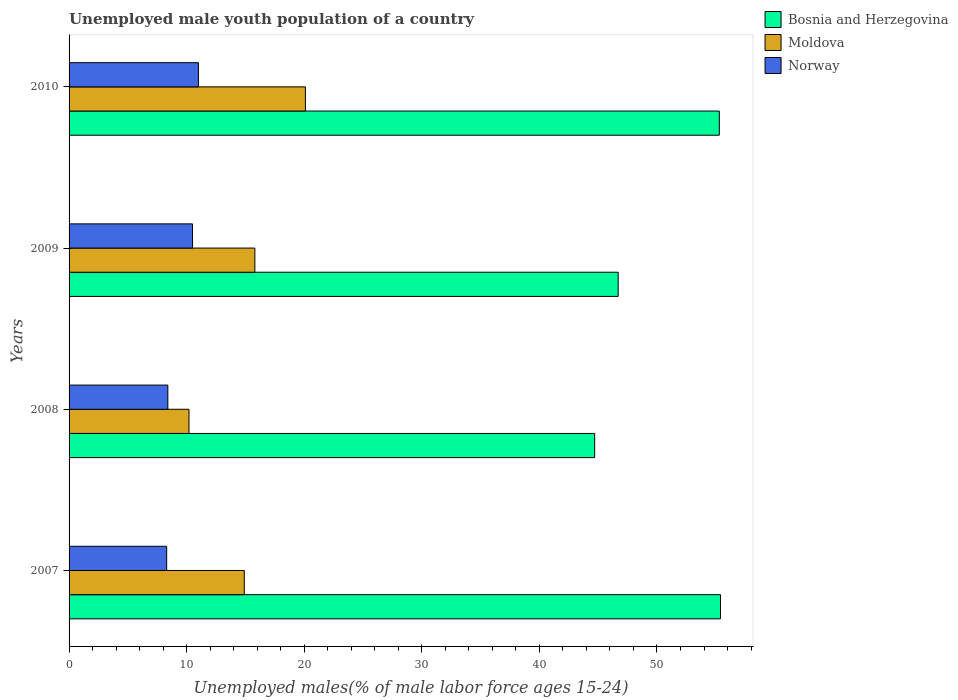How many different coloured bars are there?
Give a very brief answer. 3. How many groups of bars are there?
Give a very brief answer. 4. Are the number of bars per tick equal to the number of legend labels?
Make the answer very short. Yes. How many bars are there on the 2nd tick from the bottom?
Provide a succinct answer. 3. What is the label of the 1st group of bars from the top?
Give a very brief answer. 2010. What is the percentage of unemployed male youth population in Moldova in 2010?
Make the answer very short. 20.1. Across all years, what is the maximum percentage of unemployed male youth population in Bosnia and Herzegovina?
Provide a succinct answer. 55.4. Across all years, what is the minimum percentage of unemployed male youth population in Moldova?
Offer a terse response. 10.2. In which year was the percentage of unemployed male youth population in Norway minimum?
Your answer should be compact. 2007. What is the total percentage of unemployed male youth population in Norway in the graph?
Offer a very short reply. 38.2. What is the difference between the percentage of unemployed male youth population in Norway in 2007 and that in 2010?
Your response must be concise. -2.7. What is the difference between the percentage of unemployed male youth population in Norway in 2010 and the percentage of unemployed male youth population in Bosnia and Herzegovina in 2008?
Your response must be concise. -33.7. What is the average percentage of unemployed male youth population in Bosnia and Herzegovina per year?
Keep it short and to the point. 50.53. In the year 2010, what is the difference between the percentage of unemployed male youth population in Bosnia and Herzegovina and percentage of unemployed male youth population in Norway?
Provide a succinct answer. 44.3. What is the ratio of the percentage of unemployed male youth population in Norway in 2008 to that in 2010?
Your response must be concise. 0.76. What is the difference between the highest and the second highest percentage of unemployed male youth population in Moldova?
Your answer should be compact. 4.3. What is the difference between the highest and the lowest percentage of unemployed male youth population in Moldova?
Make the answer very short. 9.9. In how many years, is the percentage of unemployed male youth population in Moldova greater than the average percentage of unemployed male youth population in Moldova taken over all years?
Provide a short and direct response. 2. What does the 2nd bar from the top in 2007 represents?
Your answer should be compact. Moldova. Are all the bars in the graph horizontal?
Your answer should be compact. Yes. What is the difference between two consecutive major ticks on the X-axis?
Your answer should be compact. 10. Are the values on the major ticks of X-axis written in scientific E-notation?
Provide a short and direct response. No. Does the graph contain any zero values?
Offer a terse response. No. Does the graph contain grids?
Your answer should be compact. No. How many legend labels are there?
Keep it short and to the point. 3. What is the title of the graph?
Ensure brevity in your answer.  Unemployed male youth population of a country. What is the label or title of the X-axis?
Keep it short and to the point. Unemployed males(% of male labor force ages 15-24). What is the Unemployed males(% of male labor force ages 15-24) of Bosnia and Herzegovina in 2007?
Provide a short and direct response. 55.4. What is the Unemployed males(% of male labor force ages 15-24) in Moldova in 2007?
Keep it short and to the point. 14.9. What is the Unemployed males(% of male labor force ages 15-24) of Norway in 2007?
Give a very brief answer. 8.3. What is the Unemployed males(% of male labor force ages 15-24) of Bosnia and Herzegovina in 2008?
Your response must be concise. 44.7. What is the Unemployed males(% of male labor force ages 15-24) in Moldova in 2008?
Your answer should be compact. 10.2. What is the Unemployed males(% of male labor force ages 15-24) of Norway in 2008?
Your response must be concise. 8.4. What is the Unemployed males(% of male labor force ages 15-24) in Bosnia and Herzegovina in 2009?
Offer a very short reply. 46.7. What is the Unemployed males(% of male labor force ages 15-24) in Moldova in 2009?
Your response must be concise. 15.8. What is the Unemployed males(% of male labor force ages 15-24) of Norway in 2009?
Offer a terse response. 10.5. What is the Unemployed males(% of male labor force ages 15-24) in Bosnia and Herzegovina in 2010?
Your answer should be very brief. 55.3. What is the Unemployed males(% of male labor force ages 15-24) of Moldova in 2010?
Your answer should be compact. 20.1. What is the Unemployed males(% of male labor force ages 15-24) of Norway in 2010?
Ensure brevity in your answer.  11. Across all years, what is the maximum Unemployed males(% of male labor force ages 15-24) of Bosnia and Herzegovina?
Give a very brief answer. 55.4. Across all years, what is the maximum Unemployed males(% of male labor force ages 15-24) in Moldova?
Your answer should be very brief. 20.1. Across all years, what is the minimum Unemployed males(% of male labor force ages 15-24) in Bosnia and Herzegovina?
Ensure brevity in your answer.  44.7. Across all years, what is the minimum Unemployed males(% of male labor force ages 15-24) in Moldova?
Ensure brevity in your answer.  10.2. Across all years, what is the minimum Unemployed males(% of male labor force ages 15-24) of Norway?
Provide a short and direct response. 8.3. What is the total Unemployed males(% of male labor force ages 15-24) of Bosnia and Herzegovina in the graph?
Provide a short and direct response. 202.1. What is the total Unemployed males(% of male labor force ages 15-24) of Norway in the graph?
Ensure brevity in your answer.  38.2. What is the difference between the Unemployed males(% of male labor force ages 15-24) of Bosnia and Herzegovina in 2007 and that in 2010?
Your answer should be compact. 0.1. What is the difference between the Unemployed males(% of male labor force ages 15-24) in Moldova in 2007 and that in 2010?
Offer a terse response. -5.2. What is the difference between the Unemployed males(% of male labor force ages 15-24) of Norway in 2007 and that in 2010?
Your response must be concise. -2.7. What is the difference between the Unemployed males(% of male labor force ages 15-24) in Bosnia and Herzegovina in 2008 and that in 2009?
Your answer should be compact. -2. What is the difference between the Unemployed males(% of male labor force ages 15-24) of Moldova in 2008 and that in 2009?
Your answer should be compact. -5.6. What is the difference between the Unemployed males(% of male labor force ages 15-24) in Norway in 2008 and that in 2009?
Your answer should be compact. -2.1. What is the difference between the Unemployed males(% of male labor force ages 15-24) of Bosnia and Herzegovina in 2008 and that in 2010?
Make the answer very short. -10.6. What is the difference between the Unemployed males(% of male labor force ages 15-24) of Norway in 2009 and that in 2010?
Your answer should be compact. -0.5. What is the difference between the Unemployed males(% of male labor force ages 15-24) in Bosnia and Herzegovina in 2007 and the Unemployed males(% of male labor force ages 15-24) in Moldova in 2008?
Your answer should be very brief. 45.2. What is the difference between the Unemployed males(% of male labor force ages 15-24) of Bosnia and Herzegovina in 2007 and the Unemployed males(% of male labor force ages 15-24) of Norway in 2008?
Your answer should be compact. 47. What is the difference between the Unemployed males(% of male labor force ages 15-24) in Moldova in 2007 and the Unemployed males(% of male labor force ages 15-24) in Norway in 2008?
Provide a short and direct response. 6.5. What is the difference between the Unemployed males(% of male labor force ages 15-24) in Bosnia and Herzegovina in 2007 and the Unemployed males(% of male labor force ages 15-24) in Moldova in 2009?
Provide a short and direct response. 39.6. What is the difference between the Unemployed males(% of male labor force ages 15-24) in Bosnia and Herzegovina in 2007 and the Unemployed males(% of male labor force ages 15-24) in Norway in 2009?
Keep it short and to the point. 44.9. What is the difference between the Unemployed males(% of male labor force ages 15-24) of Moldova in 2007 and the Unemployed males(% of male labor force ages 15-24) of Norway in 2009?
Provide a short and direct response. 4.4. What is the difference between the Unemployed males(% of male labor force ages 15-24) in Bosnia and Herzegovina in 2007 and the Unemployed males(% of male labor force ages 15-24) in Moldova in 2010?
Keep it short and to the point. 35.3. What is the difference between the Unemployed males(% of male labor force ages 15-24) in Bosnia and Herzegovina in 2007 and the Unemployed males(% of male labor force ages 15-24) in Norway in 2010?
Provide a succinct answer. 44.4. What is the difference between the Unemployed males(% of male labor force ages 15-24) in Moldova in 2007 and the Unemployed males(% of male labor force ages 15-24) in Norway in 2010?
Your answer should be compact. 3.9. What is the difference between the Unemployed males(% of male labor force ages 15-24) of Bosnia and Herzegovina in 2008 and the Unemployed males(% of male labor force ages 15-24) of Moldova in 2009?
Ensure brevity in your answer.  28.9. What is the difference between the Unemployed males(% of male labor force ages 15-24) of Bosnia and Herzegovina in 2008 and the Unemployed males(% of male labor force ages 15-24) of Norway in 2009?
Ensure brevity in your answer.  34.2. What is the difference between the Unemployed males(% of male labor force ages 15-24) in Bosnia and Herzegovina in 2008 and the Unemployed males(% of male labor force ages 15-24) in Moldova in 2010?
Your answer should be very brief. 24.6. What is the difference between the Unemployed males(% of male labor force ages 15-24) of Bosnia and Herzegovina in 2008 and the Unemployed males(% of male labor force ages 15-24) of Norway in 2010?
Keep it short and to the point. 33.7. What is the difference between the Unemployed males(% of male labor force ages 15-24) in Moldova in 2008 and the Unemployed males(% of male labor force ages 15-24) in Norway in 2010?
Make the answer very short. -0.8. What is the difference between the Unemployed males(% of male labor force ages 15-24) in Bosnia and Herzegovina in 2009 and the Unemployed males(% of male labor force ages 15-24) in Moldova in 2010?
Provide a succinct answer. 26.6. What is the difference between the Unemployed males(% of male labor force ages 15-24) in Bosnia and Herzegovina in 2009 and the Unemployed males(% of male labor force ages 15-24) in Norway in 2010?
Offer a terse response. 35.7. What is the average Unemployed males(% of male labor force ages 15-24) of Bosnia and Herzegovina per year?
Give a very brief answer. 50.52. What is the average Unemployed males(% of male labor force ages 15-24) in Moldova per year?
Your answer should be compact. 15.25. What is the average Unemployed males(% of male labor force ages 15-24) of Norway per year?
Give a very brief answer. 9.55. In the year 2007, what is the difference between the Unemployed males(% of male labor force ages 15-24) in Bosnia and Herzegovina and Unemployed males(% of male labor force ages 15-24) in Moldova?
Provide a succinct answer. 40.5. In the year 2007, what is the difference between the Unemployed males(% of male labor force ages 15-24) in Bosnia and Herzegovina and Unemployed males(% of male labor force ages 15-24) in Norway?
Ensure brevity in your answer.  47.1. In the year 2008, what is the difference between the Unemployed males(% of male labor force ages 15-24) in Bosnia and Herzegovina and Unemployed males(% of male labor force ages 15-24) in Moldova?
Make the answer very short. 34.5. In the year 2008, what is the difference between the Unemployed males(% of male labor force ages 15-24) of Bosnia and Herzegovina and Unemployed males(% of male labor force ages 15-24) of Norway?
Give a very brief answer. 36.3. In the year 2009, what is the difference between the Unemployed males(% of male labor force ages 15-24) in Bosnia and Herzegovina and Unemployed males(% of male labor force ages 15-24) in Moldova?
Your answer should be very brief. 30.9. In the year 2009, what is the difference between the Unemployed males(% of male labor force ages 15-24) in Bosnia and Herzegovina and Unemployed males(% of male labor force ages 15-24) in Norway?
Your answer should be very brief. 36.2. In the year 2009, what is the difference between the Unemployed males(% of male labor force ages 15-24) in Moldova and Unemployed males(% of male labor force ages 15-24) in Norway?
Your answer should be very brief. 5.3. In the year 2010, what is the difference between the Unemployed males(% of male labor force ages 15-24) in Bosnia and Herzegovina and Unemployed males(% of male labor force ages 15-24) in Moldova?
Keep it short and to the point. 35.2. In the year 2010, what is the difference between the Unemployed males(% of male labor force ages 15-24) of Bosnia and Herzegovina and Unemployed males(% of male labor force ages 15-24) of Norway?
Your answer should be compact. 44.3. What is the ratio of the Unemployed males(% of male labor force ages 15-24) of Bosnia and Herzegovina in 2007 to that in 2008?
Offer a very short reply. 1.24. What is the ratio of the Unemployed males(% of male labor force ages 15-24) of Moldova in 2007 to that in 2008?
Make the answer very short. 1.46. What is the ratio of the Unemployed males(% of male labor force ages 15-24) in Norway in 2007 to that in 2008?
Your answer should be very brief. 0.99. What is the ratio of the Unemployed males(% of male labor force ages 15-24) of Bosnia and Herzegovina in 2007 to that in 2009?
Your answer should be compact. 1.19. What is the ratio of the Unemployed males(% of male labor force ages 15-24) of Moldova in 2007 to that in 2009?
Make the answer very short. 0.94. What is the ratio of the Unemployed males(% of male labor force ages 15-24) in Norway in 2007 to that in 2009?
Offer a terse response. 0.79. What is the ratio of the Unemployed males(% of male labor force ages 15-24) of Bosnia and Herzegovina in 2007 to that in 2010?
Offer a very short reply. 1. What is the ratio of the Unemployed males(% of male labor force ages 15-24) of Moldova in 2007 to that in 2010?
Make the answer very short. 0.74. What is the ratio of the Unemployed males(% of male labor force ages 15-24) of Norway in 2007 to that in 2010?
Make the answer very short. 0.75. What is the ratio of the Unemployed males(% of male labor force ages 15-24) in Bosnia and Herzegovina in 2008 to that in 2009?
Your response must be concise. 0.96. What is the ratio of the Unemployed males(% of male labor force ages 15-24) in Moldova in 2008 to that in 2009?
Provide a short and direct response. 0.65. What is the ratio of the Unemployed males(% of male labor force ages 15-24) of Bosnia and Herzegovina in 2008 to that in 2010?
Offer a very short reply. 0.81. What is the ratio of the Unemployed males(% of male labor force ages 15-24) of Moldova in 2008 to that in 2010?
Your response must be concise. 0.51. What is the ratio of the Unemployed males(% of male labor force ages 15-24) in Norway in 2008 to that in 2010?
Offer a very short reply. 0.76. What is the ratio of the Unemployed males(% of male labor force ages 15-24) of Bosnia and Herzegovina in 2009 to that in 2010?
Provide a short and direct response. 0.84. What is the ratio of the Unemployed males(% of male labor force ages 15-24) in Moldova in 2009 to that in 2010?
Keep it short and to the point. 0.79. What is the ratio of the Unemployed males(% of male labor force ages 15-24) in Norway in 2009 to that in 2010?
Your response must be concise. 0.95. What is the difference between the highest and the second highest Unemployed males(% of male labor force ages 15-24) of Bosnia and Herzegovina?
Your answer should be compact. 0.1. What is the difference between the highest and the lowest Unemployed males(% of male labor force ages 15-24) of Bosnia and Herzegovina?
Give a very brief answer. 10.7. 